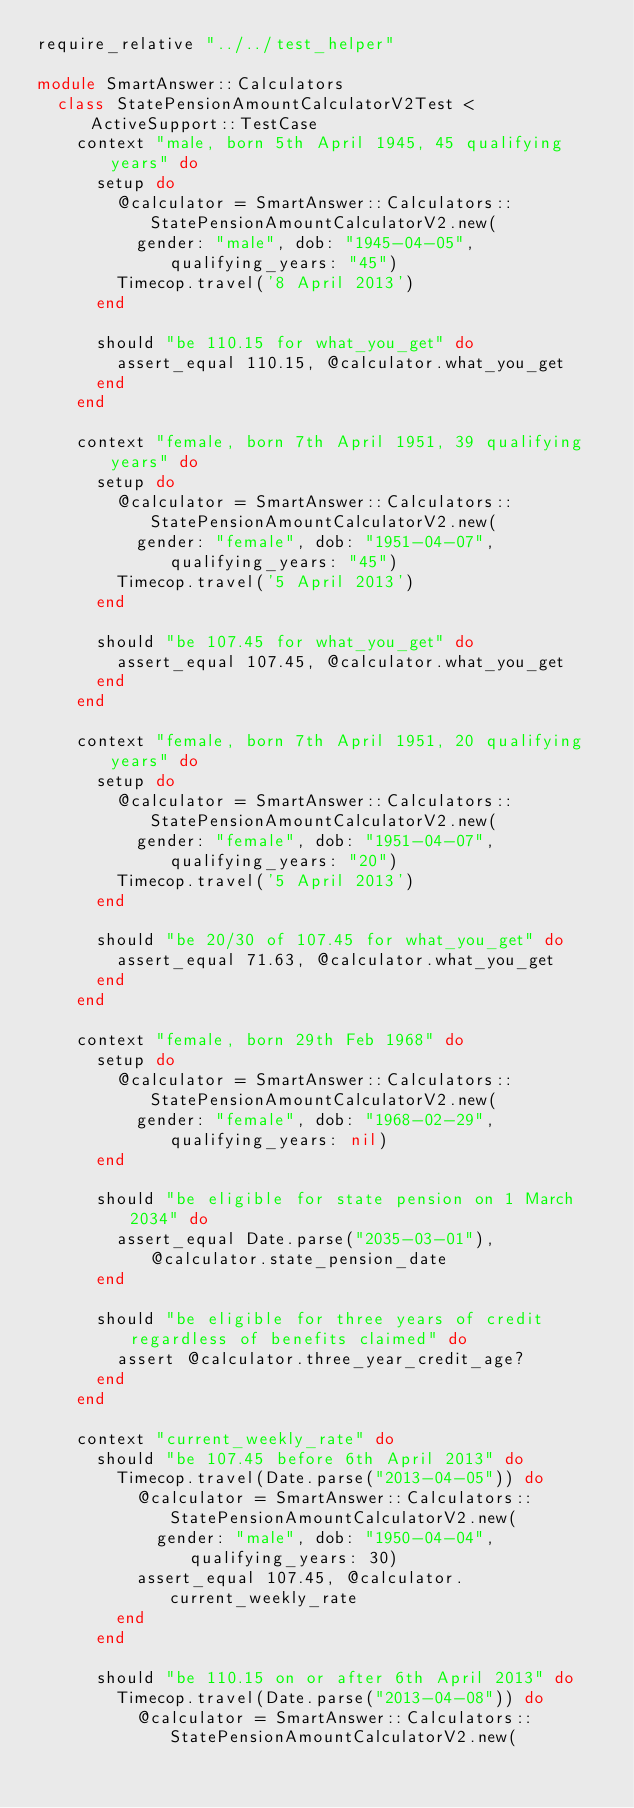Convert code to text. <code><loc_0><loc_0><loc_500><loc_500><_Ruby_>require_relative "../../test_helper"

module SmartAnswer::Calculators
  class StatePensionAmountCalculatorV2Test < ActiveSupport::TestCase
    context "male, born 5th April 1945, 45 qualifying years" do
      setup do
        @calculator = SmartAnswer::Calculators::StatePensionAmountCalculatorV2.new(
          gender: "male", dob: "1945-04-05", qualifying_years: "45")
        Timecop.travel('8 April 2013')
      end

      should "be 110.15 for what_you_get" do
        assert_equal 110.15, @calculator.what_you_get
      end
    end

    context "female, born 7th April 1951, 39 qualifying years" do
      setup do
        @calculator = SmartAnswer::Calculators::StatePensionAmountCalculatorV2.new(
          gender: "female", dob: "1951-04-07", qualifying_years: "45")
        Timecop.travel('5 April 2013')
      end

      should "be 107.45 for what_you_get" do
        assert_equal 107.45, @calculator.what_you_get
      end
    end

    context "female, born 7th April 1951, 20 qualifying years" do
      setup do
        @calculator = SmartAnswer::Calculators::StatePensionAmountCalculatorV2.new(
          gender: "female", dob: "1951-04-07", qualifying_years: "20")
        Timecop.travel('5 April 2013')
      end

      should "be 20/30 of 107.45 for what_you_get" do
        assert_equal 71.63, @calculator.what_you_get
      end
    end

    context "female, born 29th Feb 1968" do
      setup do
        @calculator = SmartAnswer::Calculators::StatePensionAmountCalculatorV2.new(
          gender: "female", dob: "1968-02-29", qualifying_years: nil)
      end

      should "be eligible for state pension on 1 March 2034" do
        assert_equal Date.parse("2035-03-01"), @calculator.state_pension_date
      end

      should "be eligible for three years of credit regardless of benefits claimed" do
        assert @calculator.three_year_credit_age?
      end
    end

    context "current_weekly_rate" do
      should "be 107.45 before 6th April 2013" do
        Timecop.travel(Date.parse("2013-04-05")) do
          @calculator = SmartAnswer::Calculators::StatePensionAmountCalculatorV2.new(
            gender: "male", dob: "1950-04-04", qualifying_years: 30)
          assert_equal 107.45, @calculator.current_weekly_rate
        end
      end

      should "be 110.15 on or after 6th April 2013" do
        Timecop.travel(Date.parse("2013-04-08")) do
          @calculator = SmartAnswer::Calculators::StatePensionAmountCalculatorV2.new(</code> 